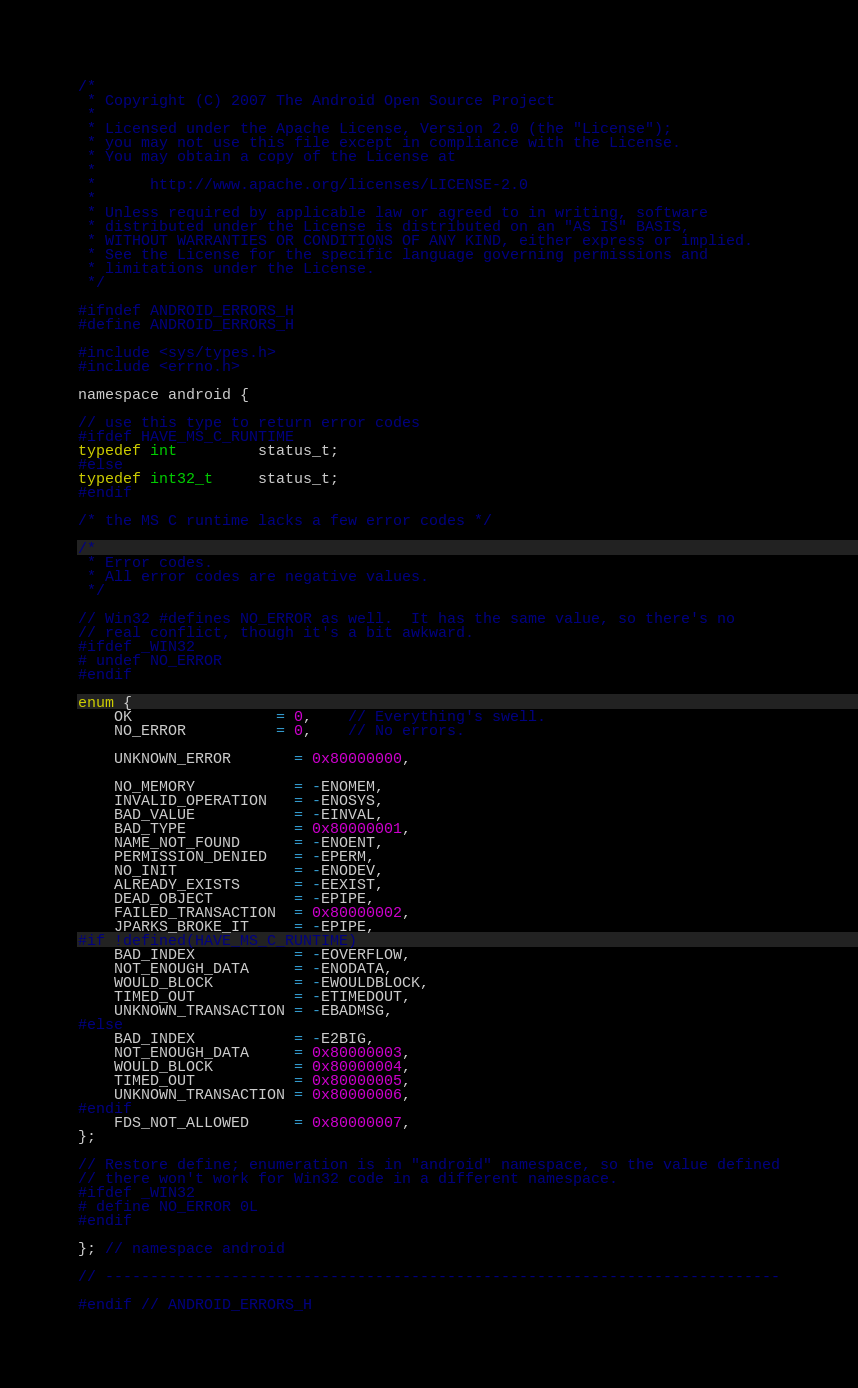Convert code to text. <code><loc_0><loc_0><loc_500><loc_500><_C_>/*
 * Copyright (C) 2007 The Android Open Source Project
 *
 * Licensed under the Apache License, Version 2.0 (the "License");
 * you may not use this file except in compliance with the License.
 * You may obtain a copy of the License at
 *
 *      http://www.apache.org/licenses/LICENSE-2.0
 *
 * Unless required by applicable law or agreed to in writing, software
 * distributed under the License is distributed on an "AS IS" BASIS,
 * WITHOUT WARRANTIES OR CONDITIONS OF ANY KIND, either express or implied.
 * See the License for the specific language governing permissions and
 * limitations under the License.
 */

#ifndef ANDROID_ERRORS_H
#define ANDROID_ERRORS_H

#include <sys/types.h>
#include <errno.h>

namespace android {

// use this type to return error codes
#ifdef HAVE_MS_C_RUNTIME
typedef int         status_t;
#else
typedef int32_t     status_t;
#endif

/* the MS C runtime lacks a few error codes */

/*
 * Error codes.
 * All error codes are negative values.
 */

// Win32 #defines NO_ERROR as well.  It has the same value, so there's no
// real conflict, though it's a bit awkward.
#ifdef _WIN32
# undef NO_ERROR
#endif

enum {
    OK                = 0,    // Everything's swell.
    NO_ERROR          = 0,    // No errors.

    UNKNOWN_ERROR       = 0x80000000,

    NO_MEMORY           = -ENOMEM,
    INVALID_OPERATION   = -ENOSYS,
    BAD_VALUE           = -EINVAL,
    BAD_TYPE            = 0x80000001,
    NAME_NOT_FOUND      = -ENOENT,
    PERMISSION_DENIED   = -EPERM,
    NO_INIT             = -ENODEV,
    ALREADY_EXISTS      = -EEXIST,
    DEAD_OBJECT         = -EPIPE,
    FAILED_TRANSACTION  = 0x80000002,
    JPARKS_BROKE_IT     = -EPIPE,
#if !defined(HAVE_MS_C_RUNTIME)
    BAD_INDEX           = -EOVERFLOW,
    NOT_ENOUGH_DATA     = -ENODATA,
    WOULD_BLOCK         = -EWOULDBLOCK,
    TIMED_OUT           = -ETIMEDOUT,
    UNKNOWN_TRANSACTION = -EBADMSG,
#else
    BAD_INDEX           = -E2BIG,
    NOT_ENOUGH_DATA     = 0x80000003,
    WOULD_BLOCK         = 0x80000004,
    TIMED_OUT           = 0x80000005,
    UNKNOWN_TRANSACTION = 0x80000006,
#endif
    FDS_NOT_ALLOWED     = 0x80000007,
};

// Restore define; enumeration is in "android" namespace, so the value defined
// there won't work for Win32 code in a different namespace.
#ifdef _WIN32
# define NO_ERROR 0L
#endif

}; // namespace android

// ---------------------------------------------------------------------------

#endif // ANDROID_ERRORS_H
</code> 